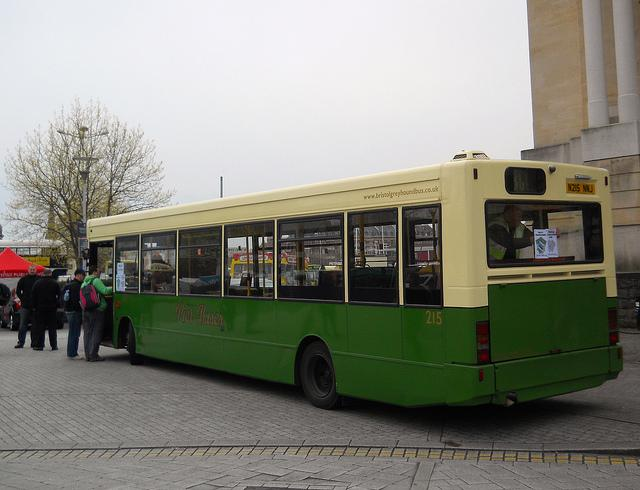In which country is this bus taking on passengers? united kingdom 